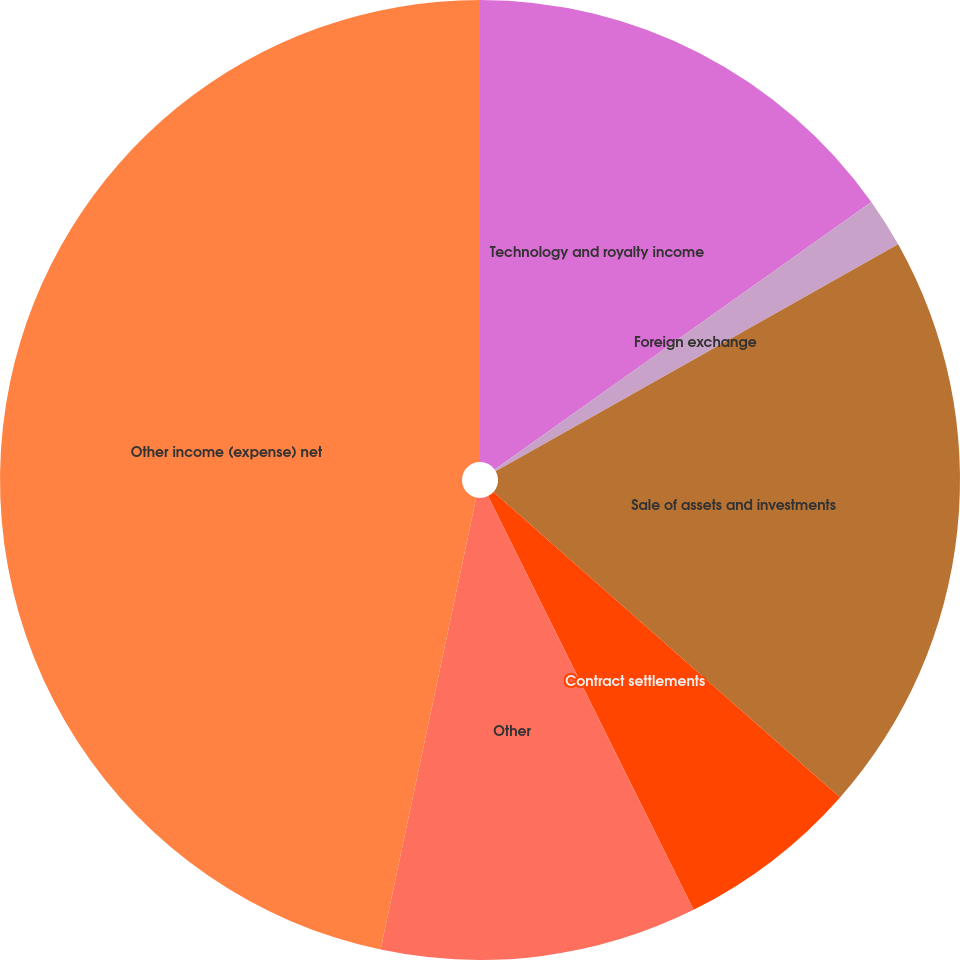Convert chart. <chart><loc_0><loc_0><loc_500><loc_500><pie_chart><fcel>Technology and royalty income<fcel>Foreign exchange<fcel>Sale of assets and investments<fcel>Contract settlements<fcel>Other<fcel>Other income (expense) net<nl><fcel>15.17%<fcel>1.66%<fcel>19.67%<fcel>6.16%<fcel>10.66%<fcel>46.68%<nl></chart> 